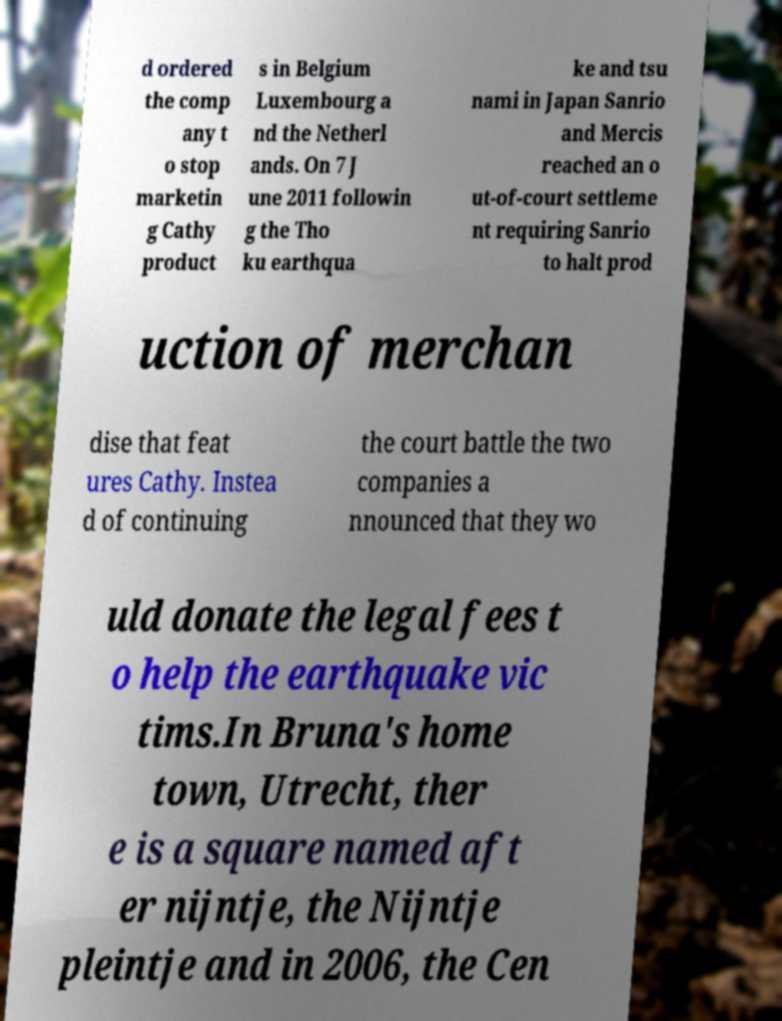Can you accurately transcribe the text from the provided image for me? d ordered the comp any t o stop marketin g Cathy product s in Belgium Luxembourg a nd the Netherl ands. On 7 J une 2011 followin g the Tho ku earthqua ke and tsu nami in Japan Sanrio and Mercis reached an o ut-of-court settleme nt requiring Sanrio to halt prod uction of merchan dise that feat ures Cathy. Instea d of continuing the court battle the two companies a nnounced that they wo uld donate the legal fees t o help the earthquake vic tims.In Bruna's home town, Utrecht, ther e is a square named aft er nijntje, the Nijntje pleintje and in 2006, the Cen 